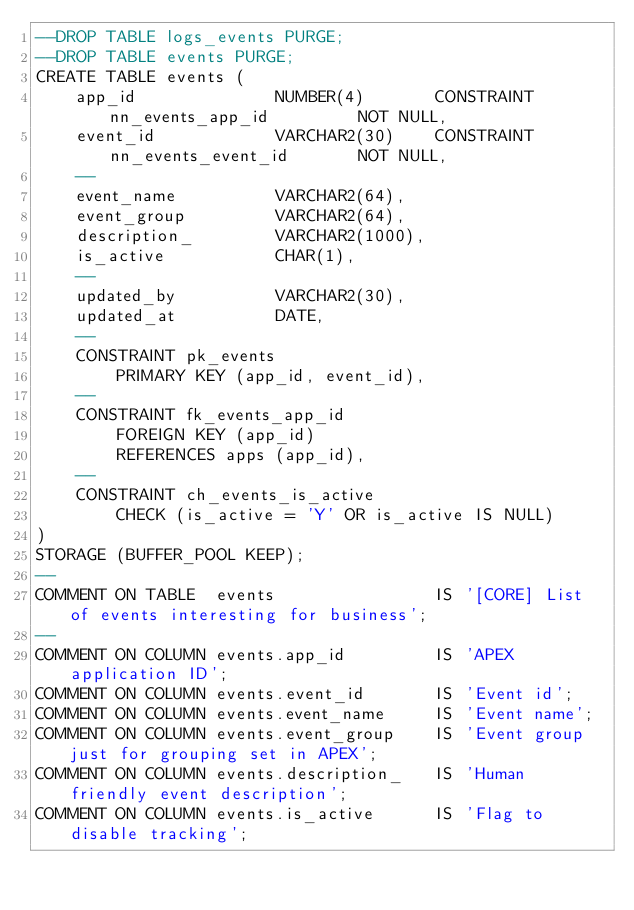<code> <loc_0><loc_0><loc_500><loc_500><_SQL_>--DROP TABLE logs_events PURGE;
--DROP TABLE events PURGE;
CREATE TABLE events (
    app_id              NUMBER(4)       CONSTRAINT nn_events_app_id         NOT NULL,
    event_id            VARCHAR2(30)    CONSTRAINT nn_events_event_id       NOT NULL,
    --
    event_name          VARCHAR2(64),
    event_group         VARCHAR2(64),
    description_        VARCHAR2(1000),
    is_active           CHAR(1),
    --
    updated_by          VARCHAR2(30),
    updated_at          DATE,
    --
    CONSTRAINT pk_events
        PRIMARY KEY (app_id, event_id),
    --
    CONSTRAINT fk_events_app_id
        FOREIGN KEY (app_id)
        REFERENCES apps (app_id),
    --
    CONSTRAINT ch_events_is_active
        CHECK (is_active = 'Y' OR is_active IS NULL)
)
STORAGE (BUFFER_POOL KEEP);
--
COMMENT ON TABLE  events                IS '[CORE] List of events interesting for business';
--
COMMENT ON COLUMN events.app_id         IS 'APEX application ID';
COMMENT ON COLUMN events.event_id       IS 'Event id';
COMMENT ON COLUMN events.event_name     IS 'Event name';
COMMENT ON COLUMN events.event_group    IS 'Event group just for grouping set in APEX';
COMMENT ON COLUMN events.description_   IS 'Human friendly event description';
COMMENT ON COLUMN events.is_active      IS 'Flag to disable tracking';

</code> 